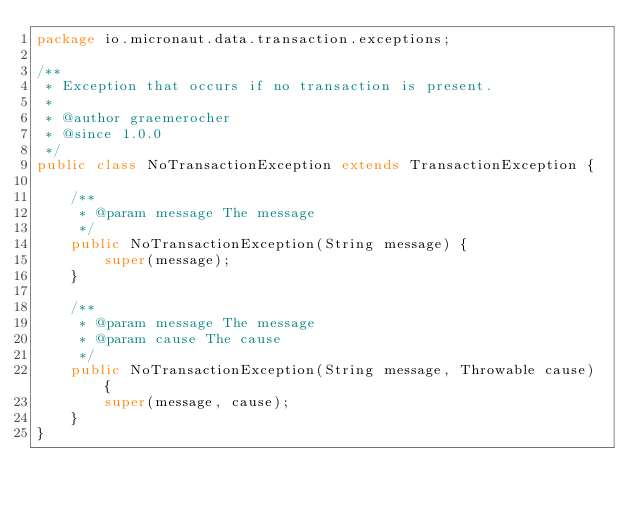Convert code to text. <code><loc_0><loc_0><loc_500><loc_500><_Java_>package io.micronaut.data.transaction.exceptions;

/**
 * Exception that occurs if no transaction is present.
 *
 * @author graemerocher
 * @since 1.0.0
 */
public class NoTransactionException extends TransactionException {

    /**
     * @param message The message
     */
    public NoTransactionException(String message) {
        super(message);
    }

    /**
     * @param message The message
     * @param cause The cause
     */
    public NoTransactionException(String message, Throwable cause) {
        super(message, cause);
    }
}
</code> 